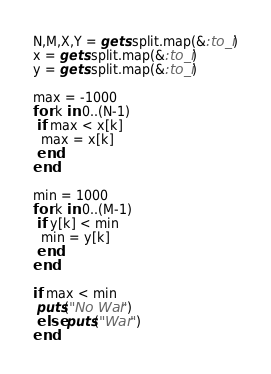Convert code to text. <code><loc_0><loc_0><loc_500><loc_500><_Ruby_>N,M,X,Y = gets.split.map(&:to_i)
x = gets.split.map(&:to_i)
y = gets.split.map(&:to_i)

max = -1000
for k in 0..(N-1)
 if max < x[k]
  max = x[k]
 end
end

min = 1000
for k in 0..(M-1)
 if y[k] < min
  min = y[k]
 end
end

if max < min
 puts("No War")
 else puts("War")
end</code> 